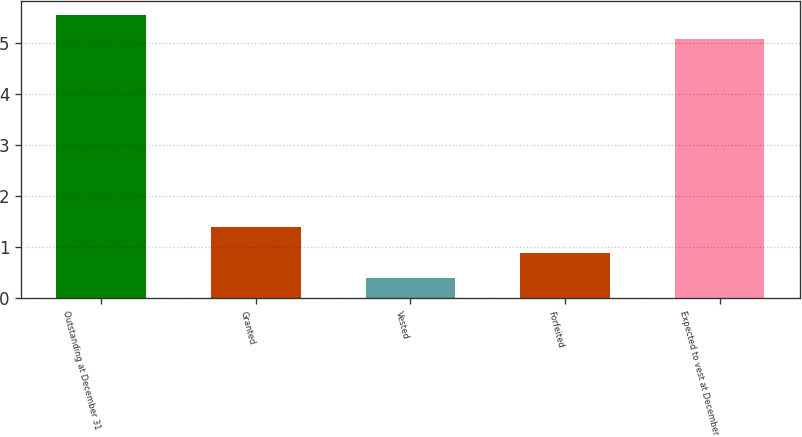<chart> <loc_0><loc_0><loc_500><loc_500><bar_chart><fcel>Outstanding at December 31<fcel>Granted<fcel>Vested<fcel>Forfeited<fcel>Expected to vest at December<nl><fcel>5.56<fcel>1.4<fcel>0.4<fcel>0.88<fcel>5.08<nl></chart> 